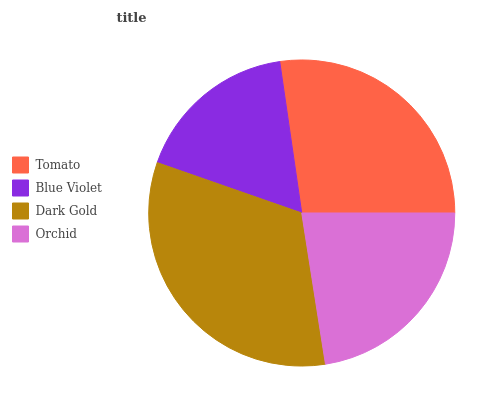Is Blue Violet the minimum?
Answer yes or no. Yes. Is Dark Gold the maximum?
Answer yes or no. Yes. Is Dark Gold the minimum?
Answer yes or no. No. Is Blue Violet the maximum?
Answer yes or no. No. Is Dark Gold greater than Blue Violet?
Answer yes or no. Yes. Is Blue Violet less than Dark Gold?
Answer yes or no. Yes. Is Blue Violet greater than Dark Gold?
Answer yes or no. No. Is Dark Gold less than Blue Violet?
Answer yes or no. No. Is Tomato the high median?
Answer yes or no. Yes. Is Orchid the low median?
Answer yes or no. Yes. Is Orchid the high median?
Answer yes or no. No. Is Blue Violet the low median?
Answer yes or no. No. 